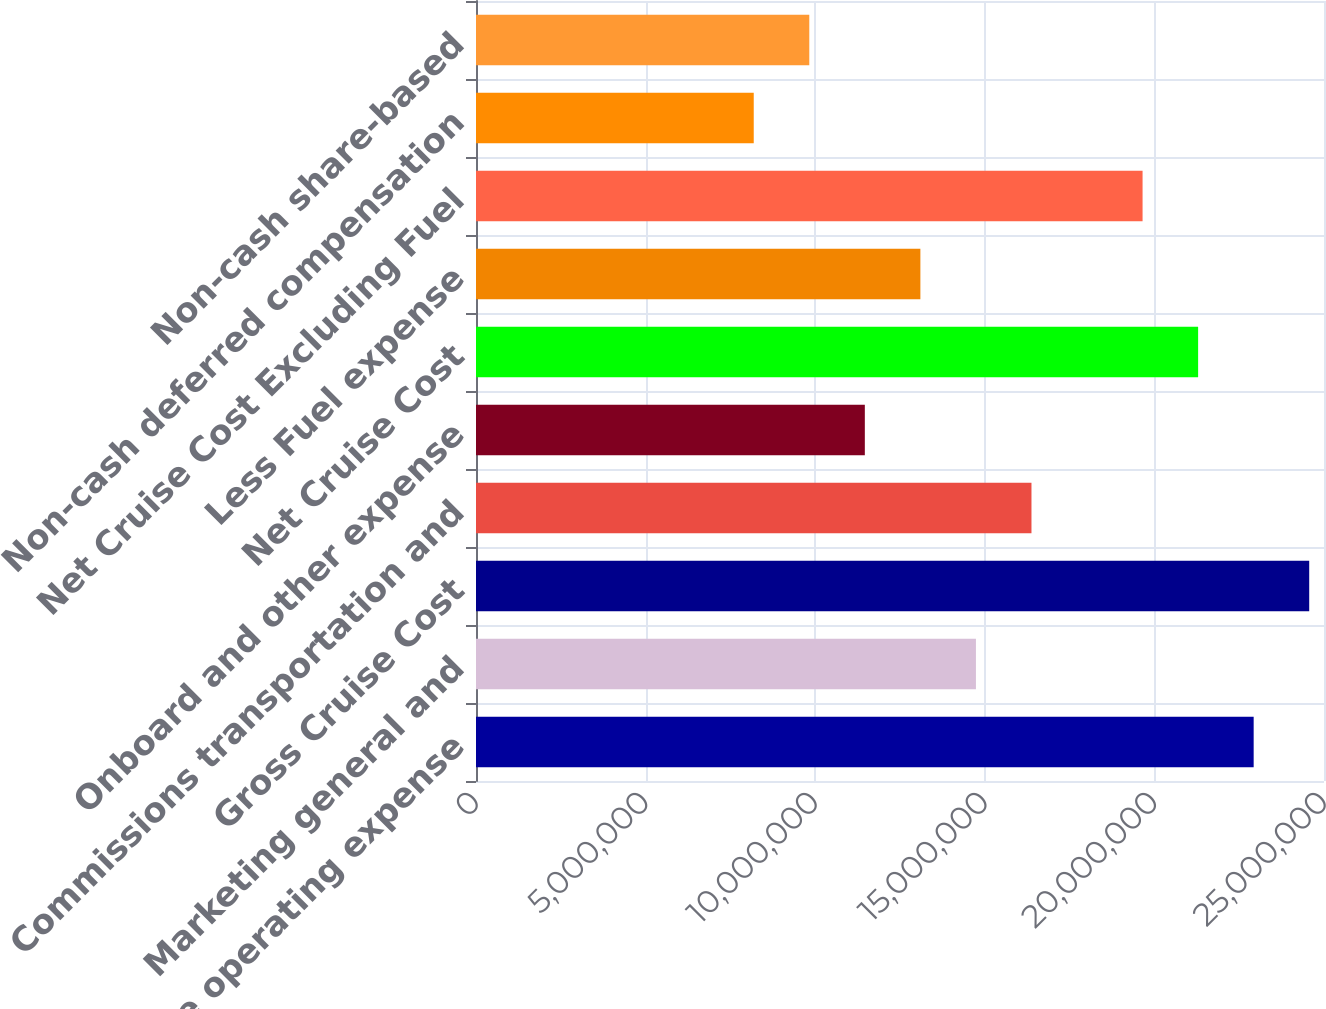<chart> <loc_0><loc_0><loc_500><loc_500><bar_chart><fcel>Total cruise operating expense<fcel>Marketing general and<fcel>Gross Cruise Cost<fcel>Commissions transportation and<fcel>Onboard and other expense<fcel>Net Cruise Cost<fcel>Less Fuel expense<fcel>Net Cruise Cost Excluding Fuel<fcel>Non-cash deferred compensation<fcel>Non-cash share-based<nl><fcel>2.29264e+07<fcel>1.47385e+07<fcel>2.4564e+07<fcel>1.63761e+07<fcel>1.14633e+07<fcel>2.12888e+07<fcel>1.31009e+07<fcel>1.96513e+07<fcel>8.18809e+06<fcel>9.82569e+06<nl></chart> 